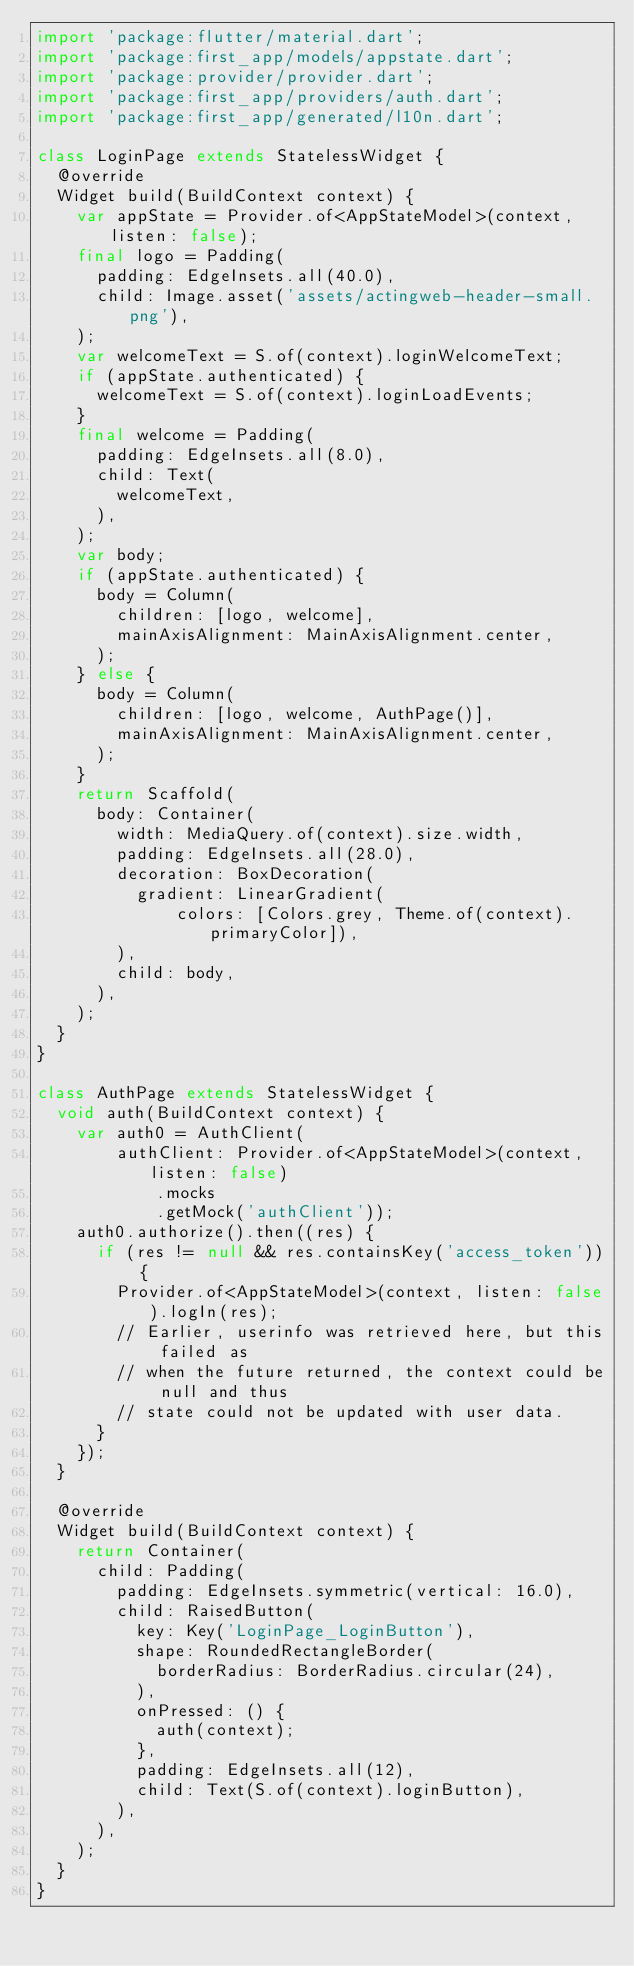<code> <loc_0><loc_0><loc_500><loc_500><_Dart_>import 'package:flutter/material.dart';
import 'package:first_app/models/appstate.dart';
import 'package:provider/provider.dart';
import 'package:first_app/providers/auth.dart';
import 'package:first_app/generated/l10n.dart';

class LoginPage extends StatelessWidget {
  @override
  Widget build(BuildContext context) {
    var appState = Provider.of<AppStateModel>(context, listen: false);
    final logo = Padding(
      padding: EdgeInsets.all(40.0),
      child: Image.asset('assets/actingweb-header-small.png'),
    );
    var welcomeText = S.of(context).loginWelcomeText;
    if (appState.authenticated) {
      welcomeText = S.of(context).loginLoadEvents;
    }
    final welcome = Padding(
      padding: EdgeInsets.all(8.0),
      child: Text(
        welcomeText,
      ),
    );
    var body;
    if (appState.authenticated) {
      body = Column(
        children: [logo, welcome],
        mainAxisAlignment: MainAxisAlignment.center,
      );
    } else {
      body = Column(
        children: [logo, welcome, AuthPage()],
        mainAxisAlignment: MainAxisAlignment.center,
      );
    }
    return Scaffold(
      body: Container(
        width: MediaQuery.of(context).size.width,
        padding: EdgeInsets.all(28.0),
        decoration: BoxDecoration(
          gradient: LinearGradient(
              colors: [Colors.grey, Theme.of(context).primaryColor]),
        ),
        child: body,
      ),
    );
  }
}

class AuthPage extends StatelessWidget {
  void auth(BuildContext context) {
    var auth0 = AuthClient(
        authClient: Provider.of<AppStateModel>(context, listen: false)
            .mocks
            .getMock('authClient'));
    auth0.authorize().then((res) {
      if (res != null && res.containsKey('access_token')) {
        Provider.of<AppStateModel>(context, listen: false).logIn(res);
        // Earlier, userinfo was retrieved here, but this failed as
        // when the future returned, the context could be null and thus
        // state could not be updated with user data.
      }
    });
  }

  @override
  Widget build(BuildContext context) {
    return Container(
      child: Padding(
        padding: EdgeInsets.symmetric(vertical: 16.0),
        child: RaisedButton(
          key: Key('LoginPage_LoginButton'),
          shape: RoundedRectangleBorder(
            borderRadius: BorderRadius.circular(24),
          ),
          onPressed: () {
            auth(context);
          },
          padding: EdgeInsets.all(12),
          child: Text(S.of(context).loginButton),
        ),
      ),
    );
  }
}
</code> 